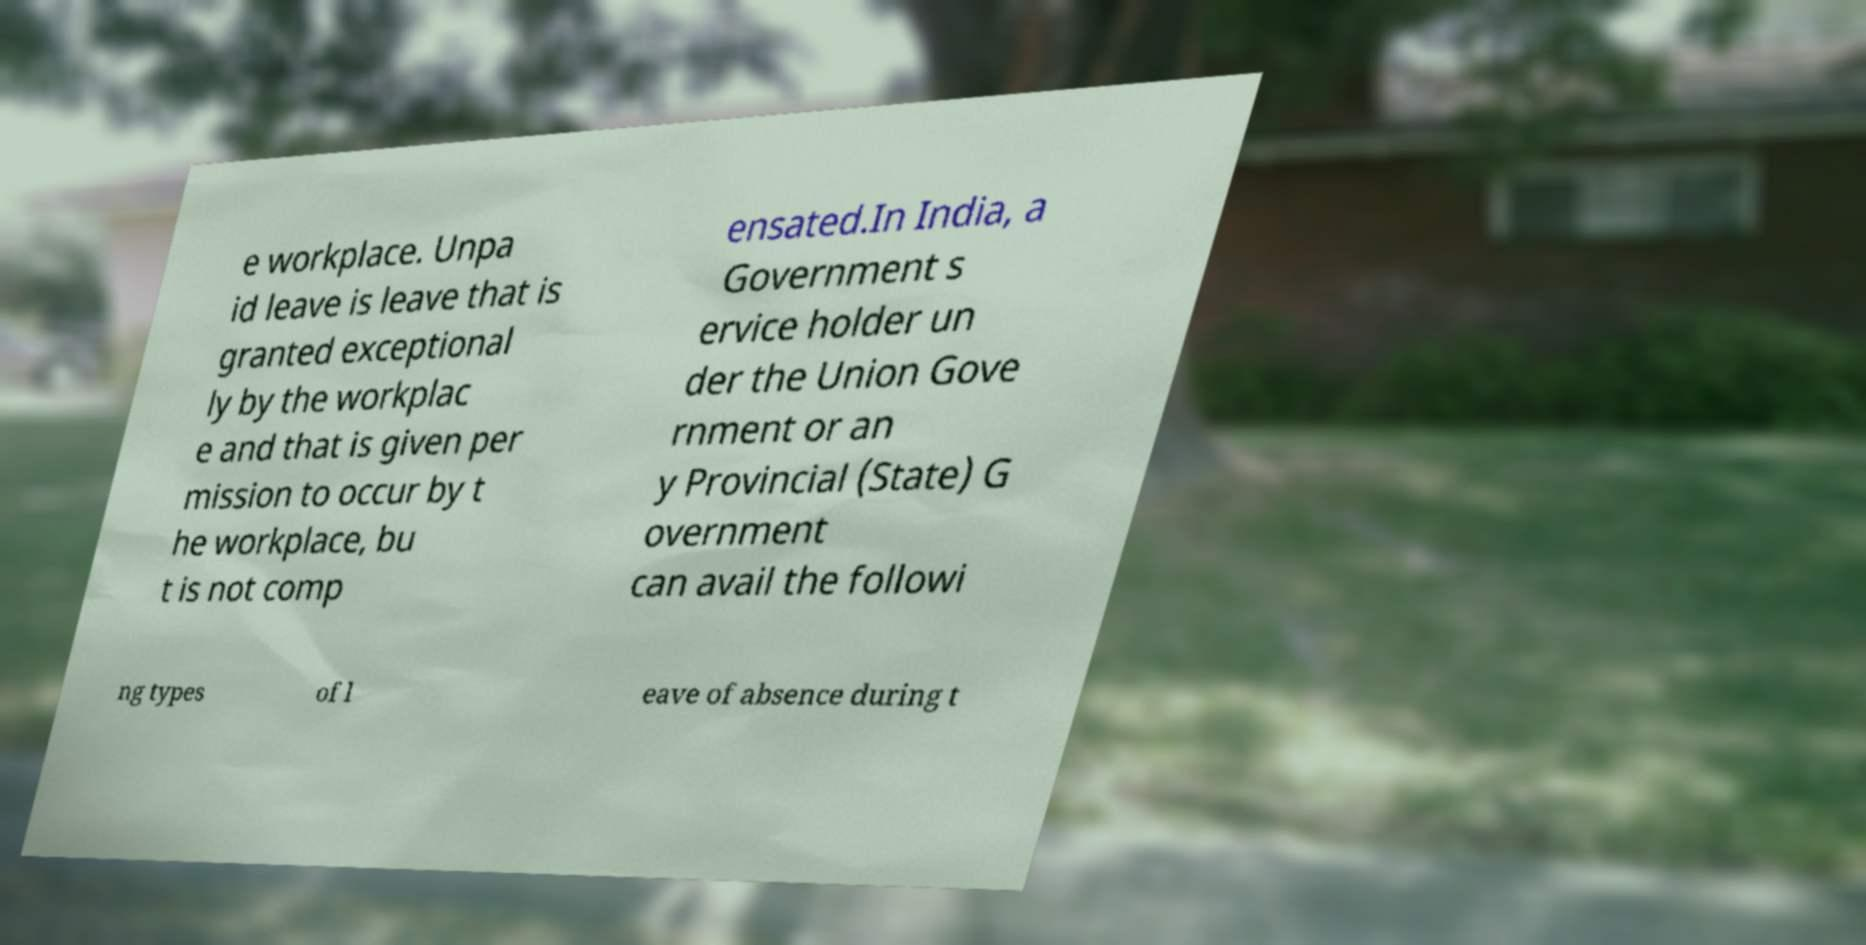Can you accurately transcribe the text from the provided image for me? e workplace. Unpa id leave is leave that is granted exceptional ly by the workplac e and that is given per mission to occur by t he workplace, bu t is not comp ensated.In India, a Government s ervice holder un der the Union Gove rnment or an y Provincial (State) G overnment can avail the followi ng types of l eave of absence during t 